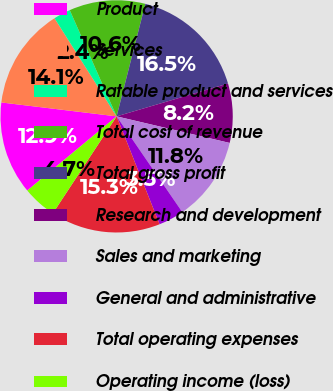Convert chart to OTSL. <chart><loc_0><loc_0><loc_500><loc_500><pie_chart><fcel>Product<fcel>Services<fcel>Ratable product and services<fcel>Total cost of revenue<fcel>Total gross profit<fcel>Research and development<fcel>Sales and marketing<fcel>General and administrative<fcel>Total operating expenses<fcel>Operating income (loss)<nl><fcel>12.94%<fcel>14.11%<fcel>2.37%<fcel>10.59%<fcel>16.46%<fcel>8.24%<fcel>11.76%<fcel>3.54%<fcel>15.29%<fcel>4.71%<nl></chart> 